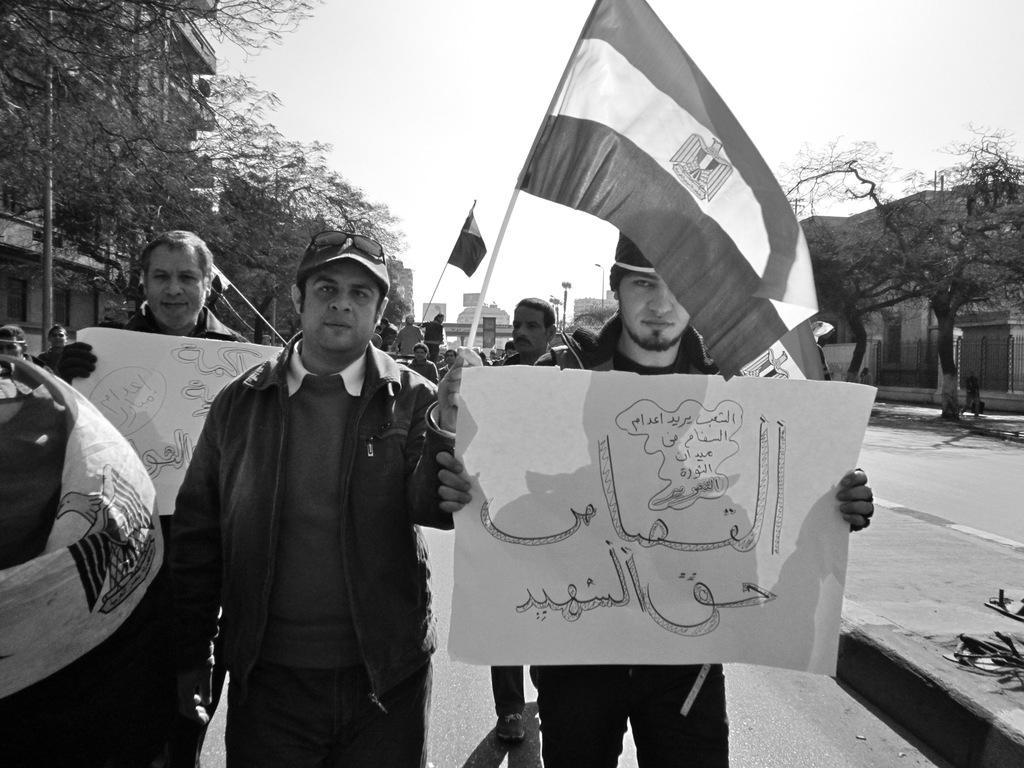In one or two sentences, can you explain what this image depicts? In this black and white image there are a few people standing, a few are holding flags and few are holding paper with some text on it. On the left and right side of the image there are buildings and trees. In the background there are a few poles, buildings, trees and the sky. 